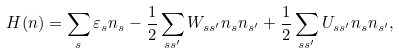Convert formula to latex. <formula><loc_0><loc_0><loc_500><loc_500>H ( n ) = \sum _ { s } \varepsilon _ { s } n _ { s } - \frac { 1 } { 2 } \sum _ { s s ^ { \prime } } W _ { s s ^ { \prime } } n _ { s } n _ { s ^ { \prime } } + \frac { 1 } { 2 } \sum _ { s s ^ { \prime } } U _ { s s ^ { \prime } } n _ { s } n _ { s ^ { \prime } } ,</formula> 